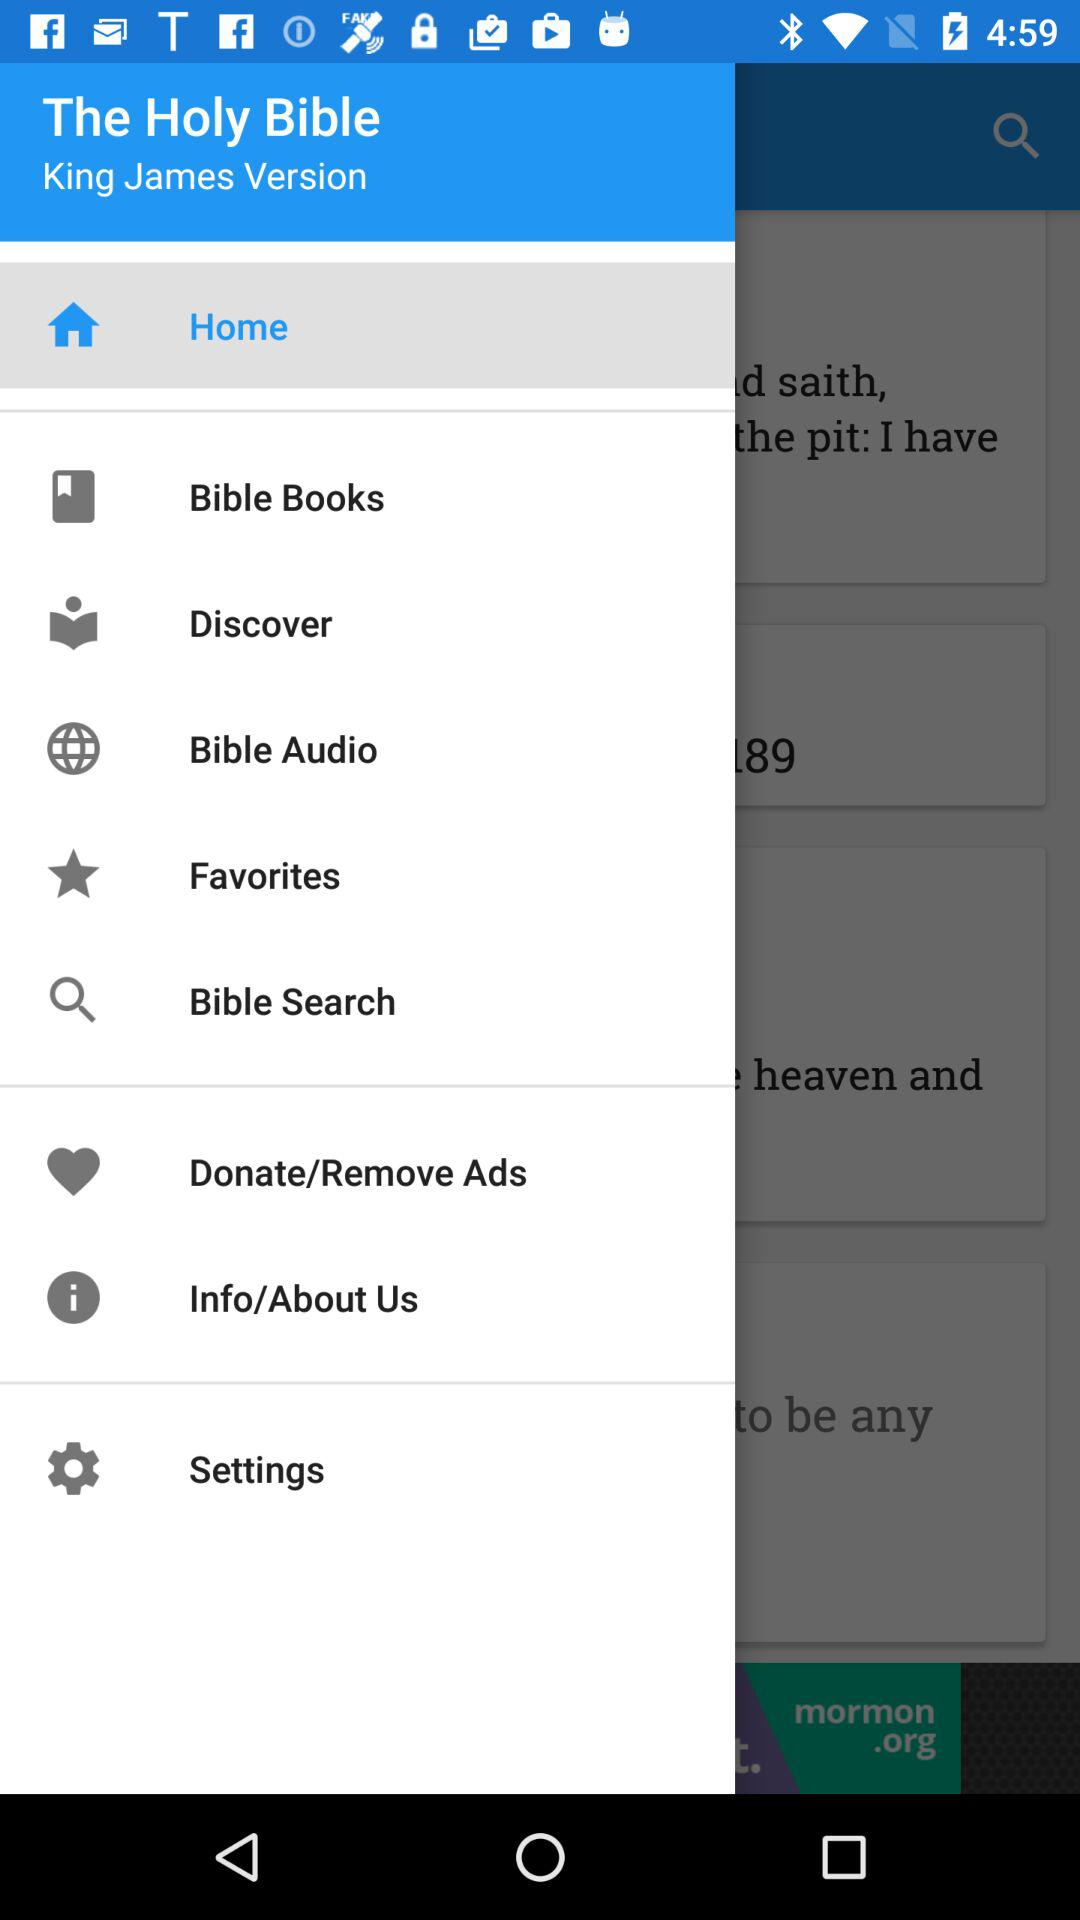What is the version?
When the provided information is insufficient, respond with <no answer>. <no answer> 